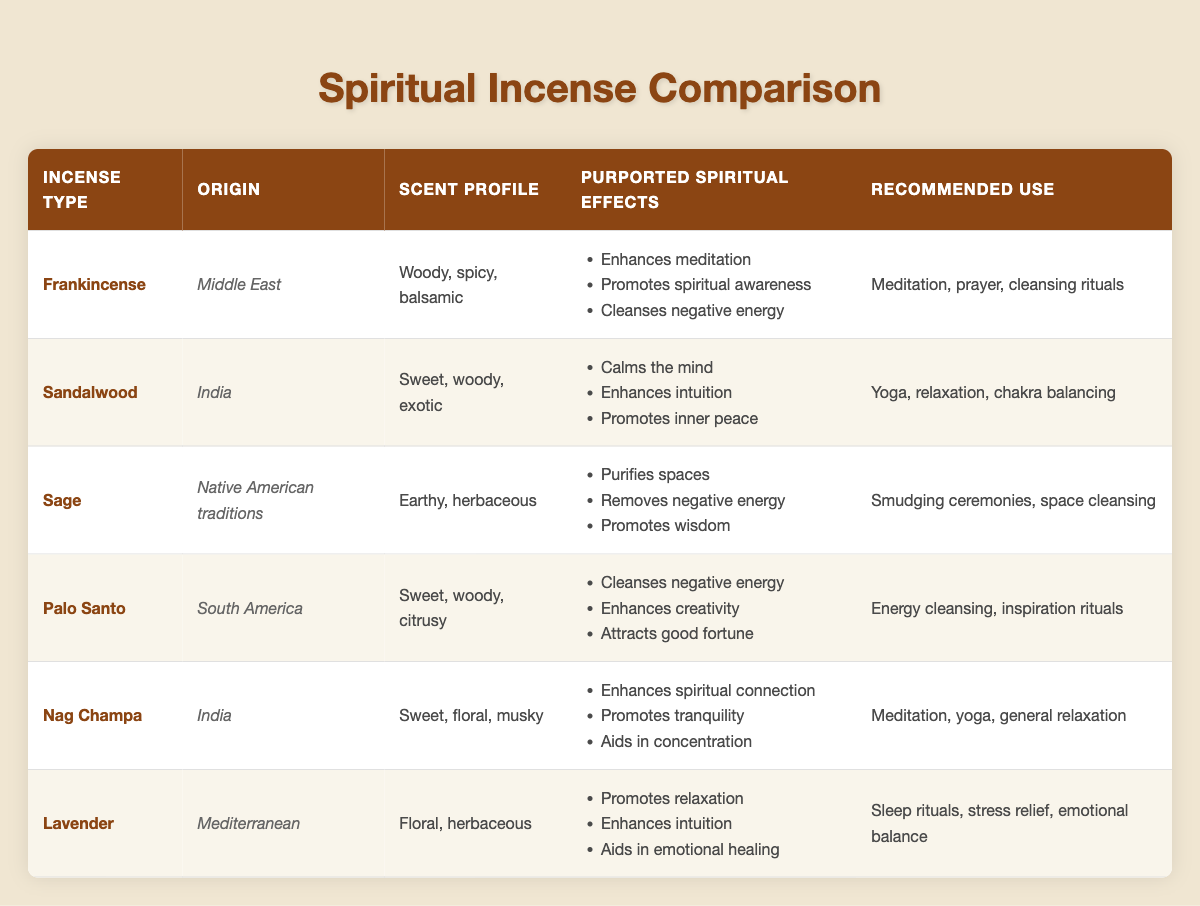What is the origin of Lavender incense? The table indicates that Lavender incense originates from the Mediterranean.
Answer: Mediterranean Which incense type is known for promoting spiritual awareness? According to the table, Frankincense is specifically noted for enhancing meditation and promoting spiritual awareness.
Answer: Frankincense How many purported spiritual effects does Palo Santo have? By examining the Palo Santo row in the table, it is evident that it has three listed purported spiritual effects.
Answer: 3 Is Sandalwood recommended for smudging ceremonies? The table shows that Sandalwood is recommended for yoga, relaxation, and chakra balancing, but not for smudging ceremonies, which is associated with Sage.
Answer: No Which incense type has a sweet, floral, musky scent profile and promotes tranquility? Referring to the table, Nag Champa has a sweet, floral, musky scent profile and is noted for promoting tranquility.
Answer: Nag Champa If I want to cleanse negative energy, which incense options do I have? The incense types with the purported effect of cleansing negative energy, according to the table, are Frankincense, Sage, and Palo Santo.
Answer: Frankincense, Sage, Palo Santo Which incense type has the fewest recommended uses? By comparing the recommended use column, Sandalwood appears to be the only one with three specific uses (yoga, relaxation, chakra balancing), while other incense types have more varied applications.
Answer: Sandalwood What is the combined number of purported spiritual effects for Lavender and Nag Champa? Lavender has three purported spiritual effects, and Nag Champa also has three. Adding these together gives a combined total of six.
Answer: 6 Does Sage promote emotional healing? The table states that Sage's effects include purifying spaces, removing negative energy, and promoting wisdom, but it does not indicate emotional healing, which is associated with Lavender.
Answer: No 